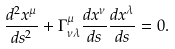<formula> <loc_0><loc_0><loc_500><loc_500>\frac { d ^ { 2 } x ^ { \mu } } { d s ^ { 2 } } + \Gamma ^ { \mu } _ { \nu \lambda } \frac { d x ^ { \nu } } { d s } \frac { d x ^ { \lambda } } { d s } = 0 .</formula> 